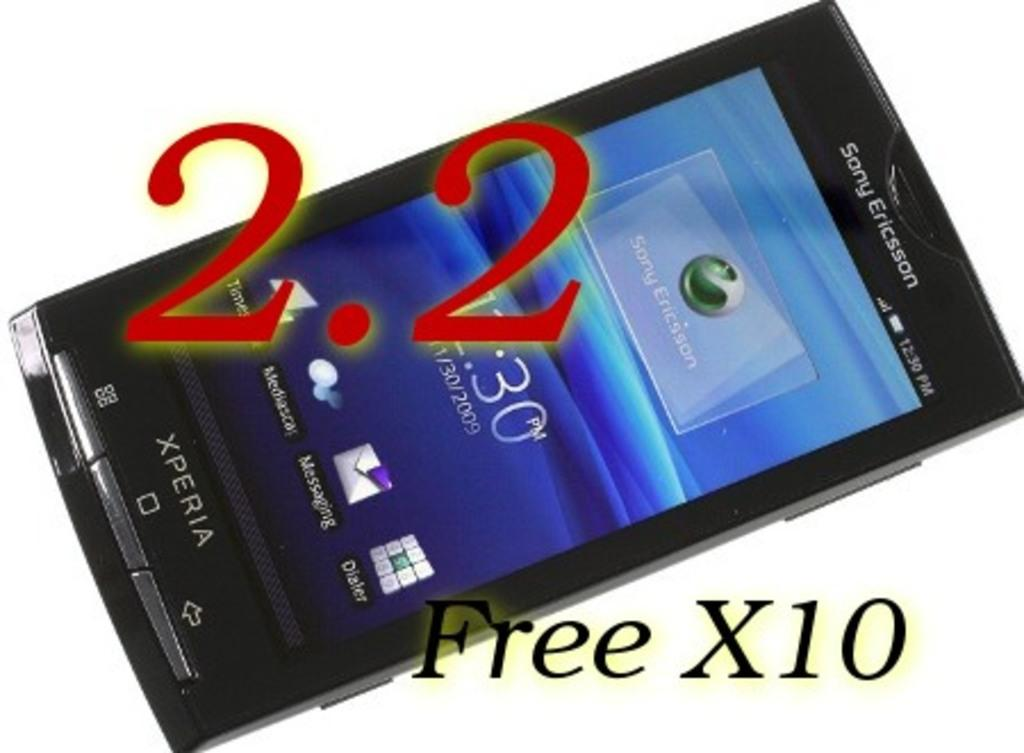<image>
Describe the image concisely. Acell phone with a Sony Ericsson label on it. 